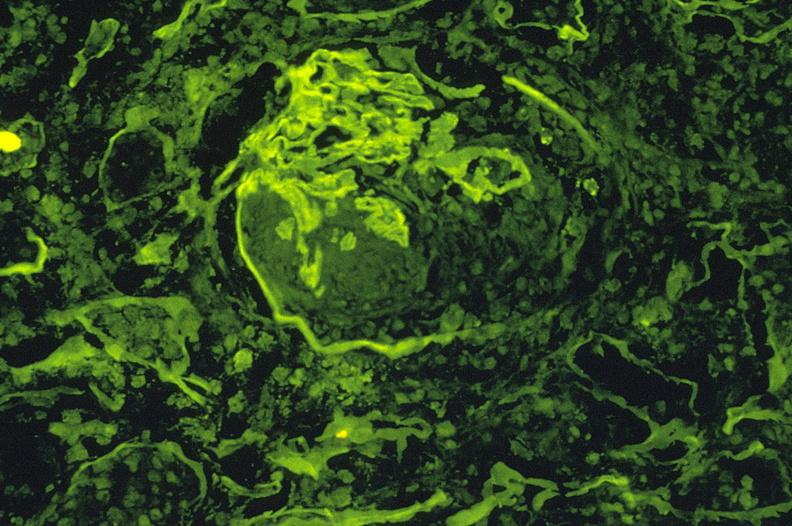what is present?
Answer the question using a single word or phrase. Urinary 